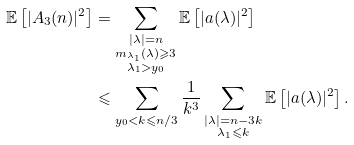Convert formula to latex. <formula><loc_0><loc_0><loc_500><loc_500>\mathbb { E } \left [ | A _ { 3 } ( n ) | ^ { 2 } \right ] & = \sum _ { \substack { | \lambda | = n \\ m _ { \lambda _ { 1 } } ( \lambda ) \geqslant 3 \\ \lambda _ { 1 } > y _ { 0 } } } \mathbb { E } \left [ | a ( \lambda ) | ^ { 2 } \right ] \\ & \leqslant \sum _ { y _ { 0 } < k \leqslant n / 3 } \frac { 1 } { k ^ { 3 } } \sum _ { \substack { | \lambda | = n - 3 k \\ \lambda _ { 1 } \leqslant k } } \mathbb { E } \left [ | a ( \lambda ) | ^ { 2 } \right ] .</formula> 